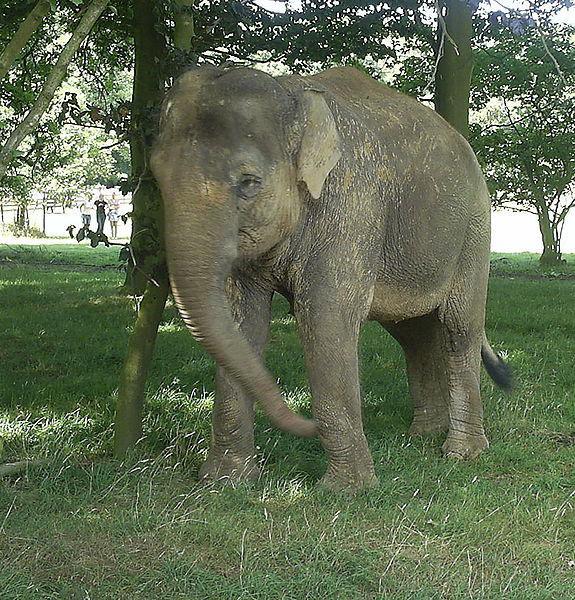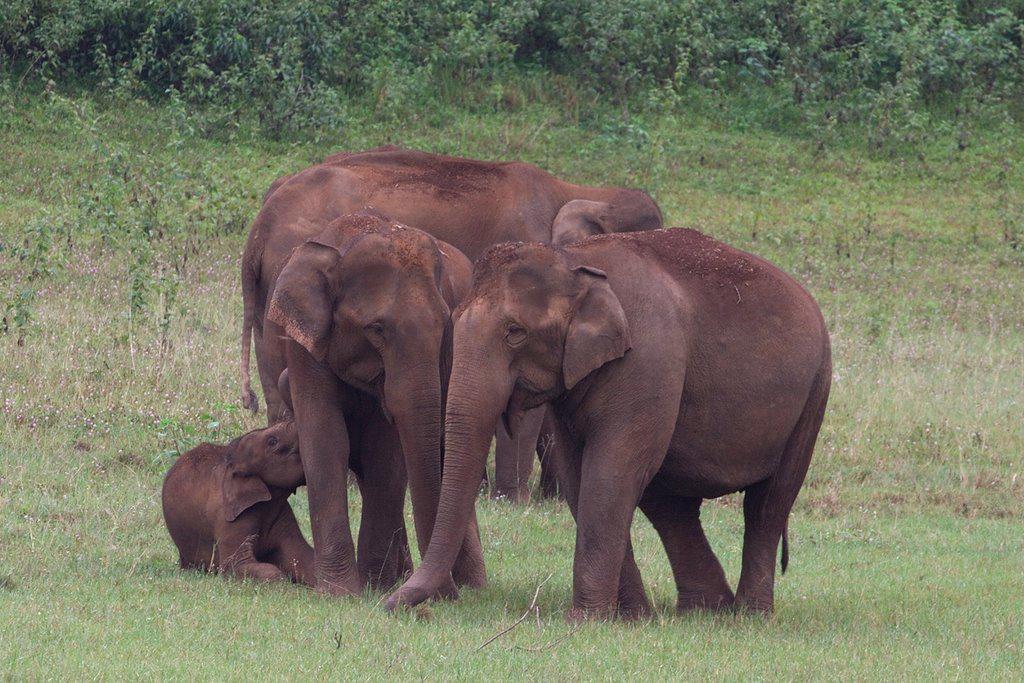The first image is the image on the left, the second image is the image on the right. Examine the images to the left and right. Is the description "There is one elephant in green grass in the image on the left." accurate? Answer yes or no. Yes. The first image is the image on the left, the second image is the image on the right. For the images shown, is this caption "An image shows a close group of exactly four elephants and includes animals of different ages." true? Answer yes or no. Yes. 